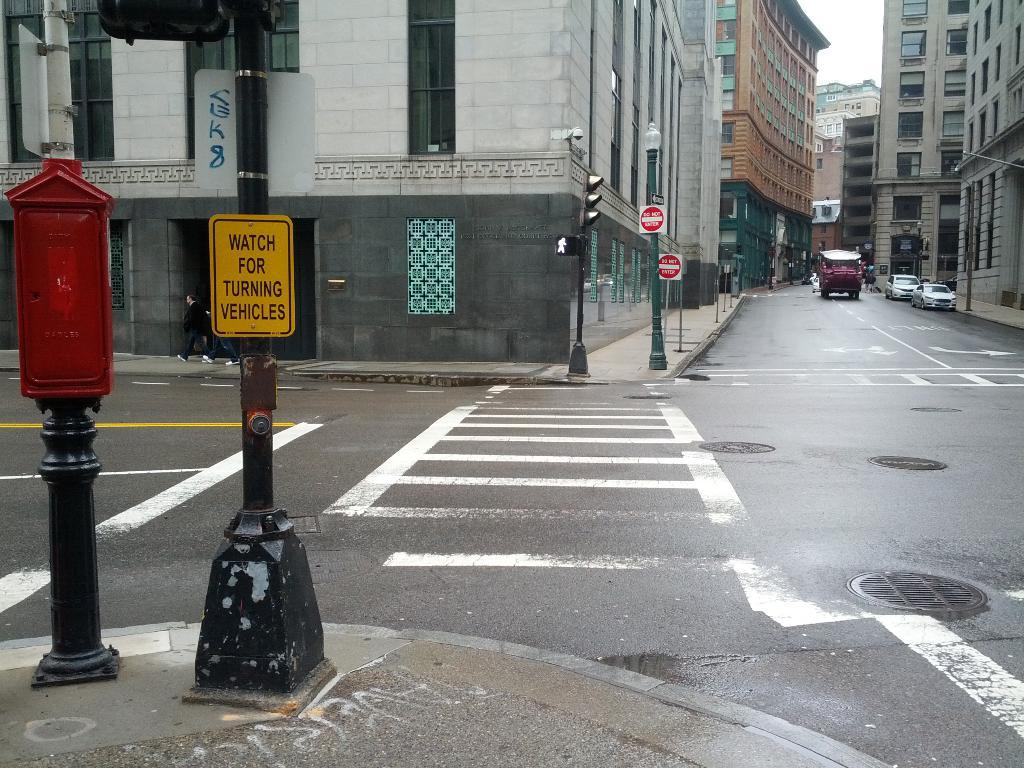Is the crosswalk safe from turning vehicles?
Your response must be concise. No. What do the signs across the street say?
Make the answer very short. Do not enter. 